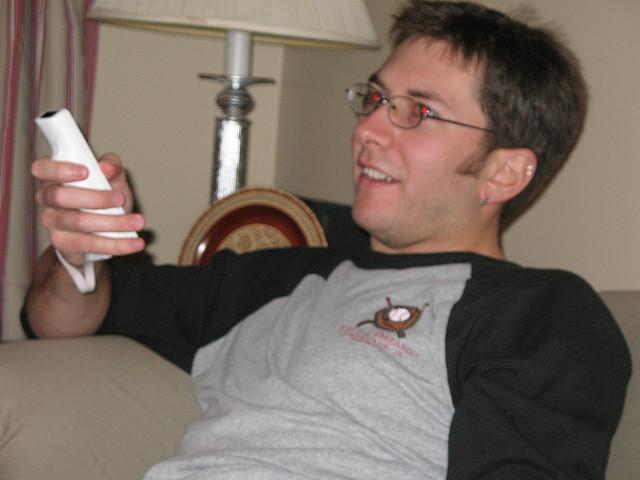What game is this man playing?
Be succinct. Wii. Does this person wear glasses?
Quick response, please. Yes. Is the guy having fun?
Concise answer only. Yes. 